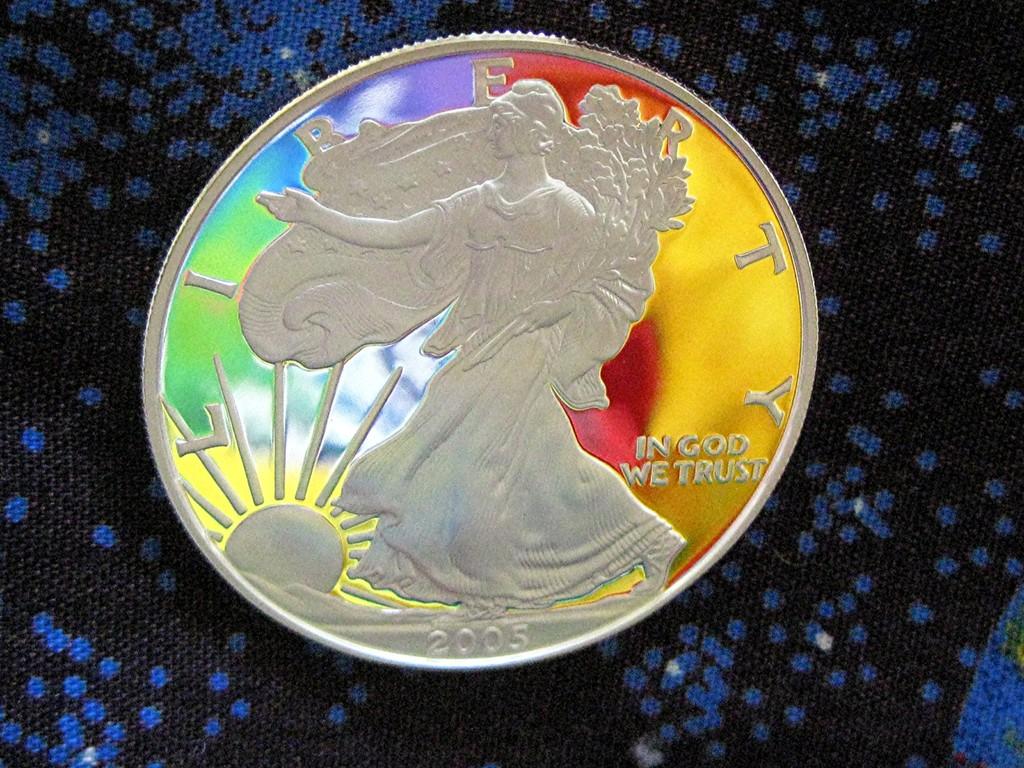In whom we trust?
Keep it short and to the point. God. 